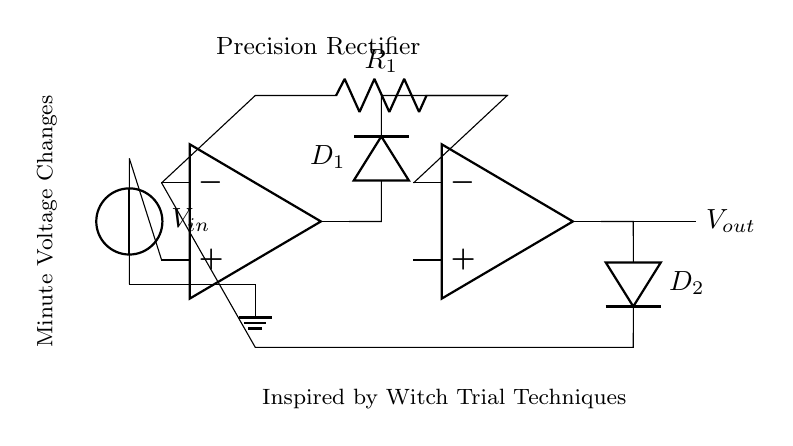What type of operational amplifiers are used in this circuit? The circuit contains two operational amplifiers, as denoted by the op amp symbols.
Answer: Two operational amplifiers What is the purpose of the diodes in this circuit? The diodes are used to ensure that only the positive voltage is passed through during rectification, which is typical in precision rectifier circuits.
Answer: Ensure positive voltage What is the value of the resistor labeled R1? The circuit does not specify an exact value for R1, only indicating it as R1 in the schematic. Hence, it is not definable.
Answer: Not defined How is the input voltage connected to the circuit? The input voltage, labeled Vin, is connected to the non-inverting terminal of the first operational amplifier, which indicates a direct connection for signal input.
Answer: Directly to op amp What type of circuit is represented by this diagram? The diagram represents a precision rectifier circuit, which is designed to accurately measure and rectify small voltage changes, especially useful in lie detector tests.
Answer: Precision rectifier How do the operational amplifiers affect the output voltage? The operational amplifiers amplify the input signal before and after rectification, thus influencing the output voltage based on the input voltage and the feedback network.
Answer: Amplify the input What does the label "Inspired by Witch Trial Techniques" imply about the circuit's purpose? The label suggests that this circuit could be used in a lie detection context, reminiscent of historical interrogation methods used during witch trials.
Answer: Lie detection context 